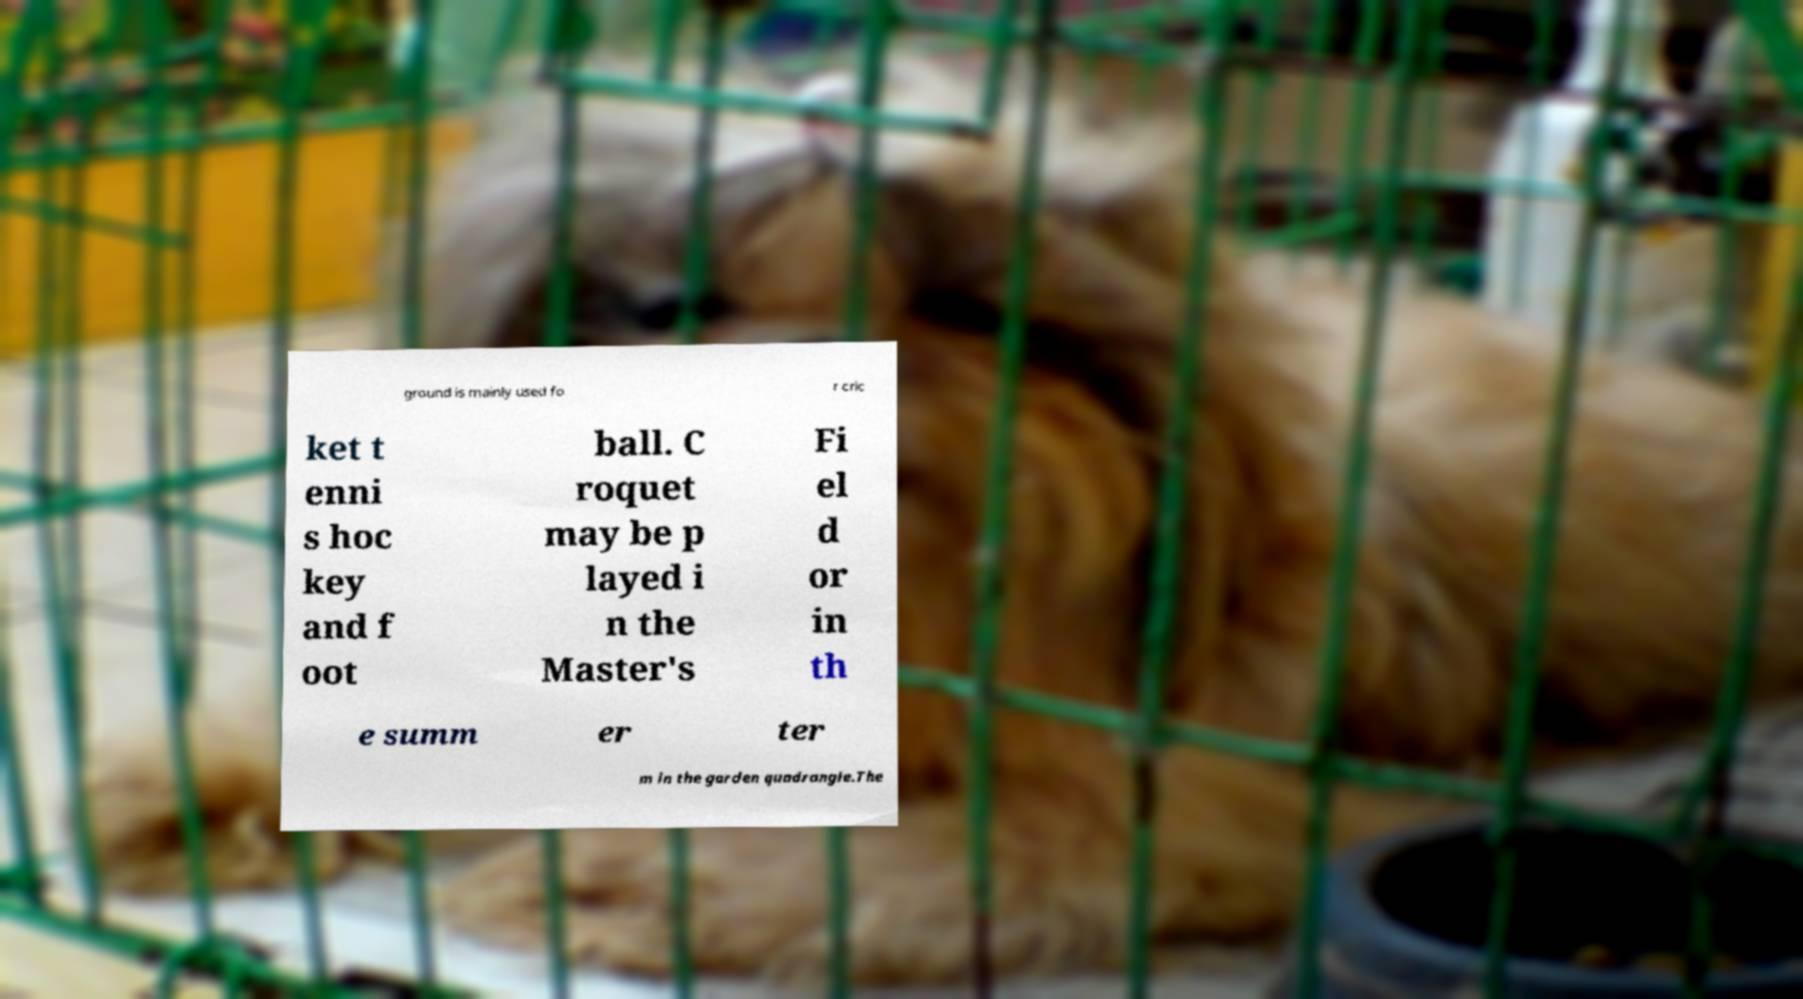For documentation purposes, I need the text within this image transcribed. Could you provide that? ground is mainly used fo r cric ket t enni s hoc key and f oot ball. C roquet may be p layed i n the Master's Fi el d or in th e summ er ter m in the garden quadrangle.The 